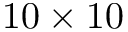Convert formula to latex. <formula><loc_0><loc_0><loc_500><loc_500>1 0 \times 1 0</formula> 